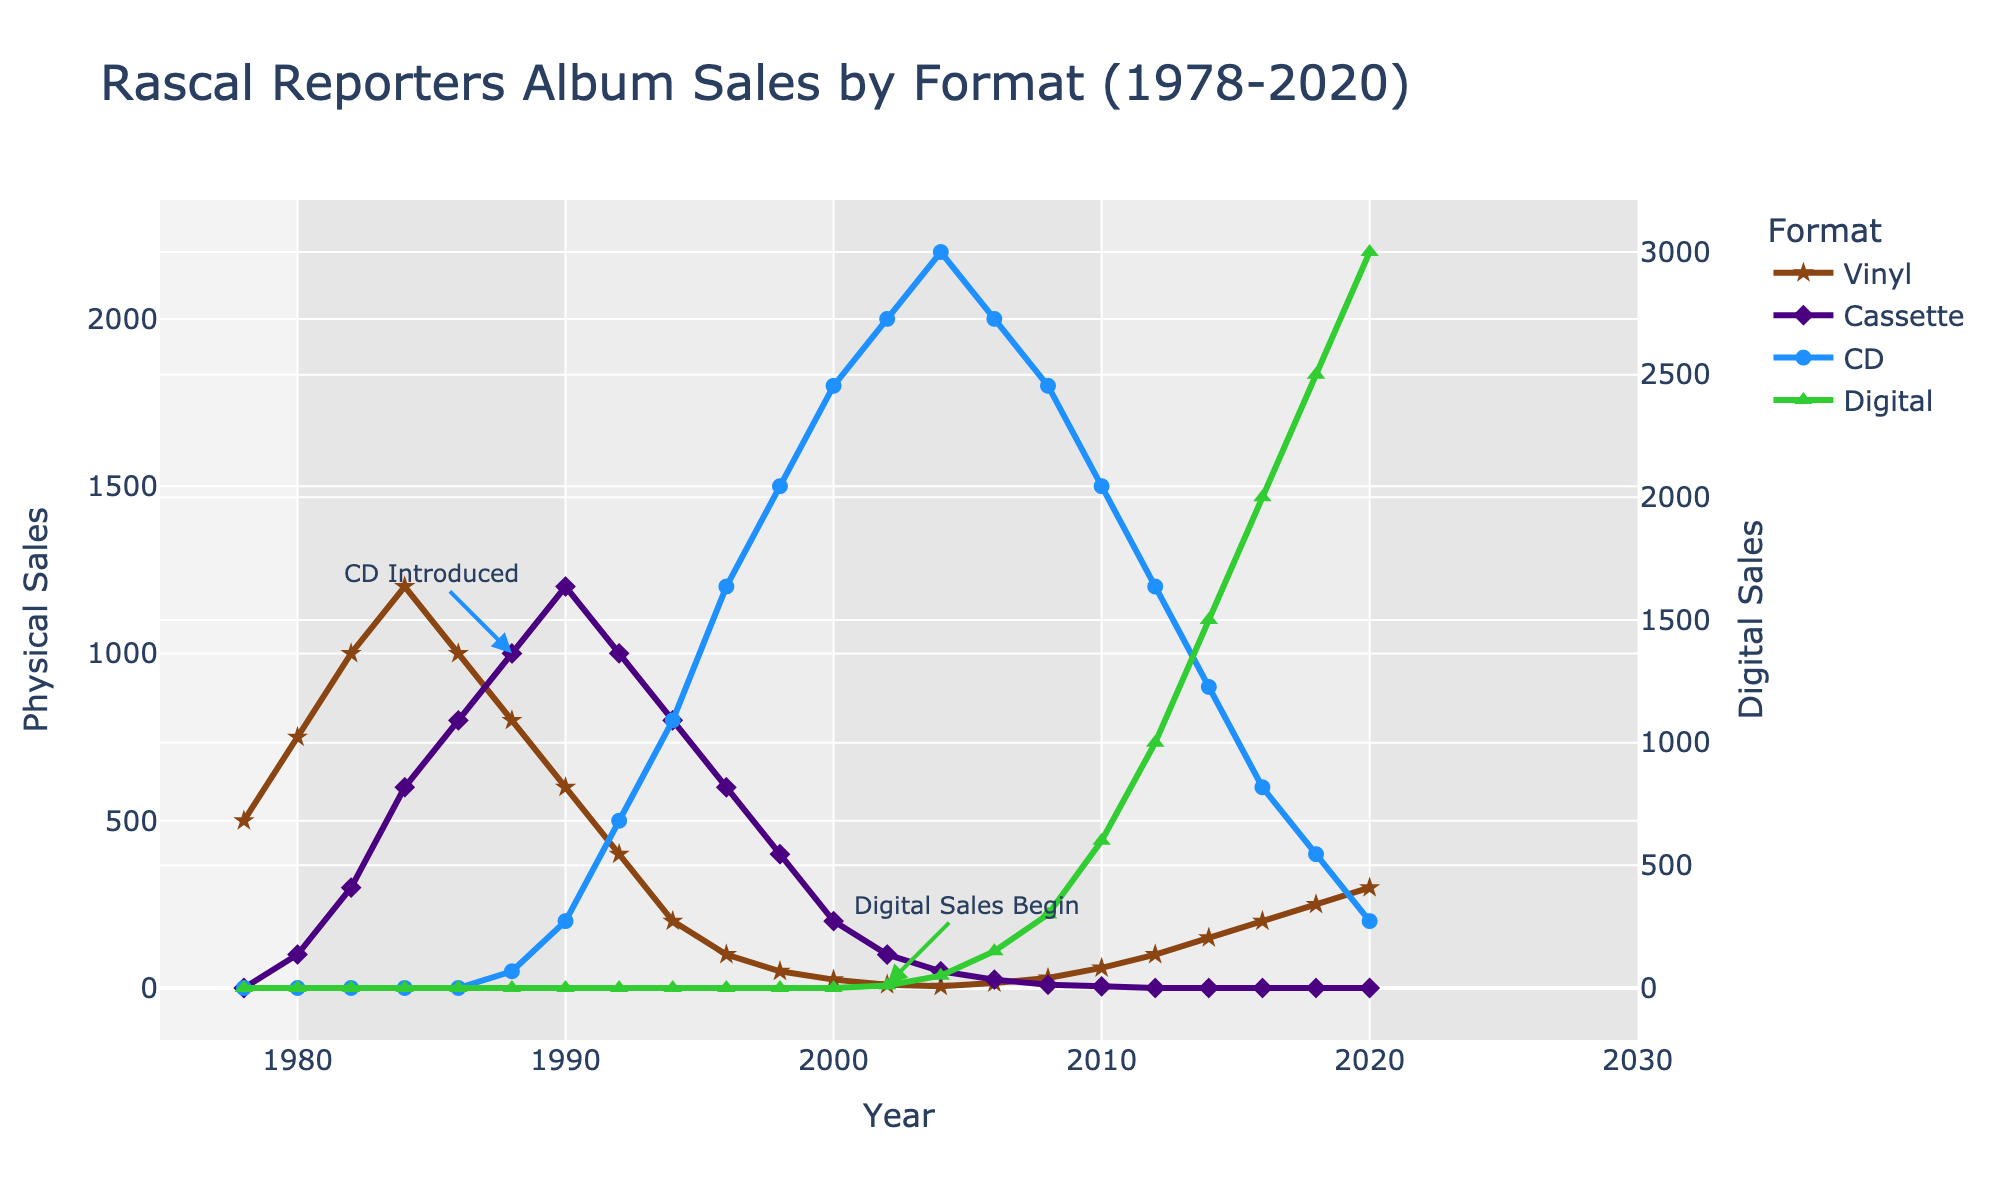What was the highest sales year for vinyl? From the figure, the peak of the vinyl sales line occurs at the highest value of 1200 in 1984.
Answer: 1984 Which format surpassed all others in sales after 2002? After 2002, the digital format shows a sharp increase and surpasses all other formats with the highest sales reaching 3000 in 2020.
Answer: Digital What's the sum of CD sales in the first five years CDs were introduced? CDs were introduced in 1988. Summing up CD sales from 1988 to 1992: 50 + 200 + 500 = 750.
Answer: 750 Between which two years did digital sales experience the largest increase? Observing the green line for digital sales, the largest increase occurs between 2018 and 2020, from 2500 to 3000.
Answer: 2018 and 2020 Which format had the steepest decline and during what period? The vinyl format experienced a steep decline from 1984 to 2004, dropping from 1200 to 5.
Answer: Vinyl (1984-2004) How do the sales of cassettes in 1990 compare to the sales of vinyl in the same year? In 1990, cassette sales were 1200 while vinyl sales were 600; thus, cassette sales were exactly double the vinyl sales.
Answer: Cassette sales were double In what year did CD sales peak and what was the value? The CD sales peak is observed in 2004 with a value of 2200.
Answer: 2004 and 2200 How many years after its introduction did digital sales reach 1000? Digital sales reached 1000 by the year 2012, starting from 2002. This took 10 years.
Answer: 10 years What's the average of digital sales from 2002 to 2020? Summing digital sales from 2002 to 2020: 10 + 50 + 150 + 300 + 600 + 1000 + 1500 + 2000 + 2500 + 3000 = 11110. With 10 years in total, the average is 11110 / 10 = 1111.
Answer: 1111 Which formats were completely phased out by 2014? By 2014, the cassette format had sales reduced to 0, indicating it was phased out.
Answer: Cassette 